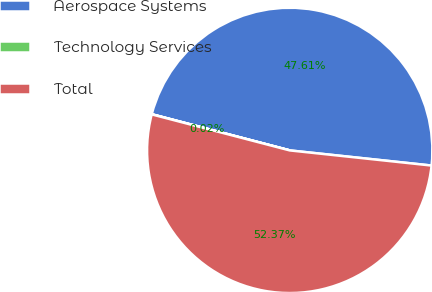<chart> <loc_0><loc_0><loc_500><loc_500><pie_chart><fcel>Aerospace Systems<fcel>Technology Services<fcel>Total<nl><fcel>47.61%<fcel>0.02%<fcel>52.37%<nl></chart> 